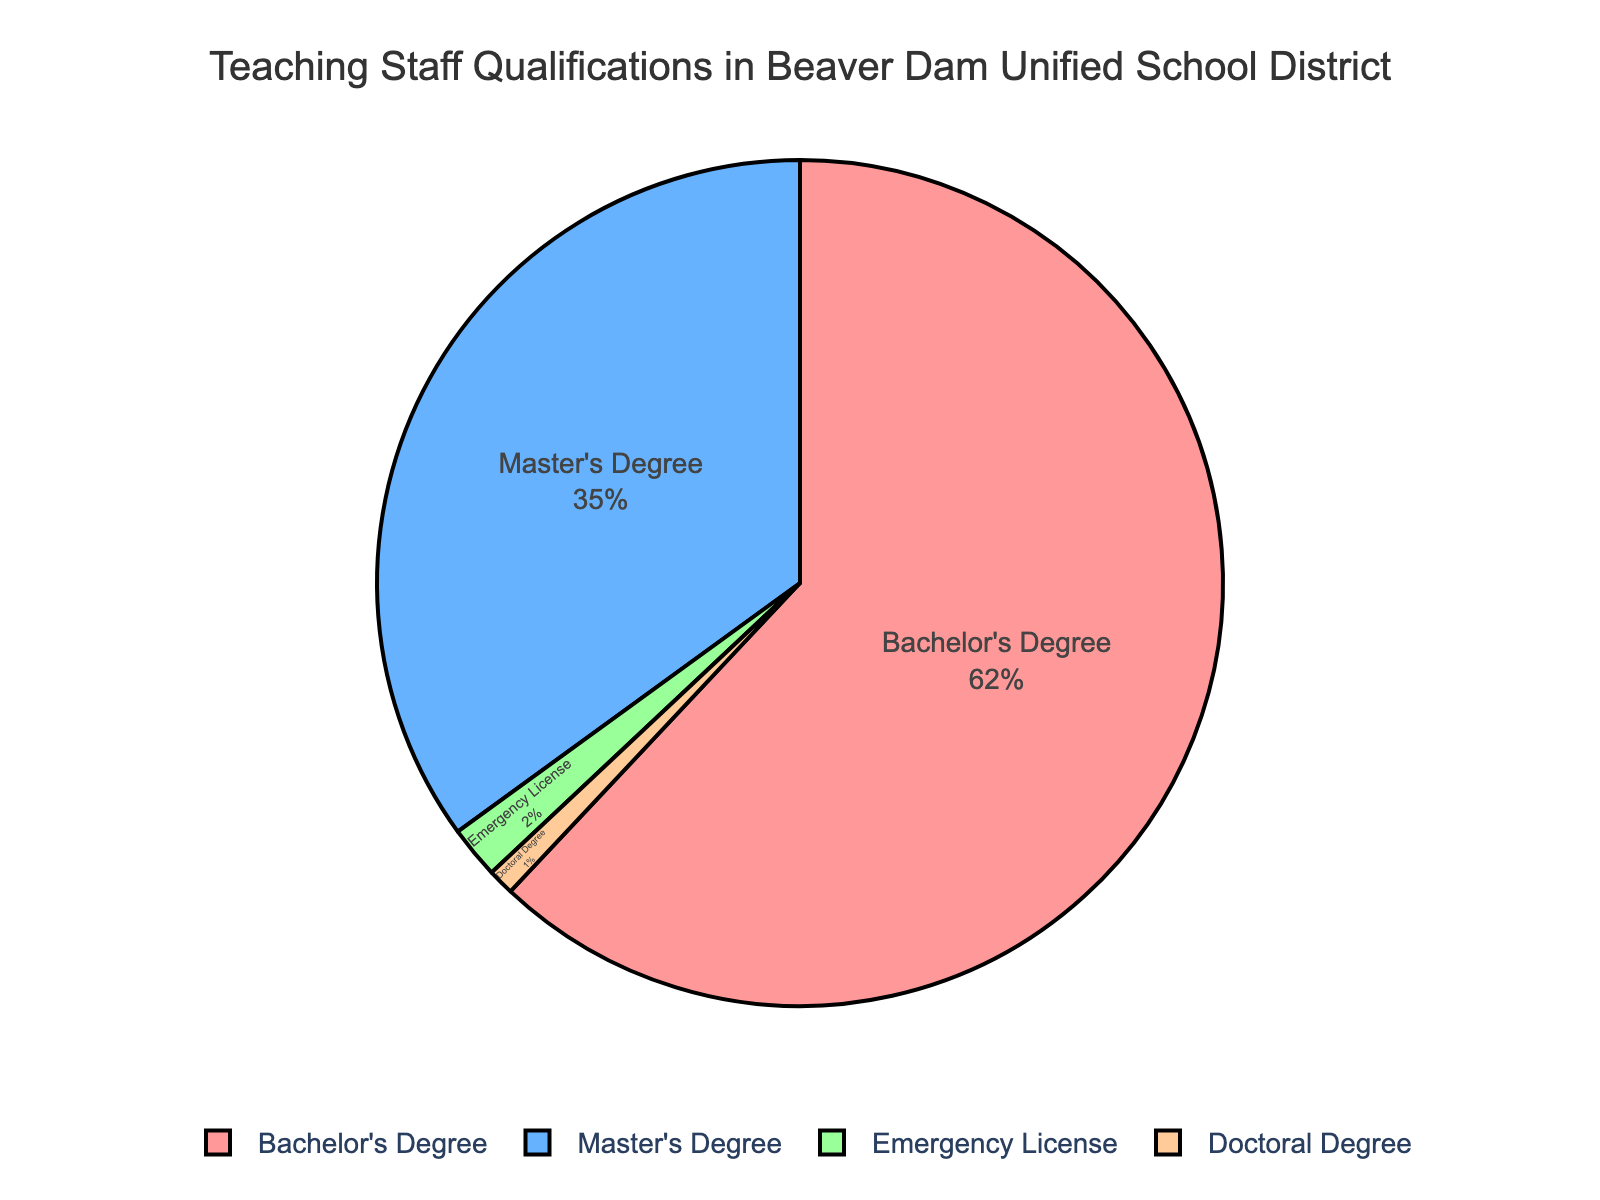What percentage of teachers in the Beaver Dam Unified School District have a Master's Degree? By examining the pie chart, we can see the segment labeled "Master's Degree" and its corresponding percentage.
Answer: 35% What is the difference in percentage between teachers with a Bachelor's Degree and those with an Emergency License? Subtract the percentage of teachers with an Emergency License from those with a Bachelor's Degree (62% - 2%).
Answer: 60% What percentage of teachers in the Beaver Dam Unified School District have advanced degrees (Master's or Doctoral)? Sum the percentages of teachers with Master's Degrees and Doctoral Degrees (35% + 1%).
Answer: 36% Which category has the smallest representation among the teaching staff in Beaver Dam Unified School District? Identify the smallest segment on the pie chart, labeled "Doctoral Degree."
Answer: Doctoral Degree How much larger is the percentage of teachers with a Master's Degree compared to those with a Doctoral Degree? Subtract the percentage of teachers with a Doctoral Degree from those with a Master's Degree (35% - 1%).
Answer: 34% What is the total percentage of teachers who do not have a standard degree (i.e., those with an Emergency License)? Locate the segment labeled "Emergency License" and note its percentage.
Answer: 2% How do the percentages of teachers with Bachelor's Degrees and Master's Degrees compare visually in terms of size on the pie chart? Observe the relative size of the segments labeled "Bachelor's Degree" and "Master's Degree"; the Bachelor's Degree segment is noticeably larger.
Answer: Bachelor's Degree segment is larger If you combine teachers with Emergency Licenses and Doctoral Degrees, what percentage of the total teaching staff do they represent? Sum the percentages for Emergency Licenses and Doctoral Degrees (2% + 1%).
Answer: 3% Among the qualifications listed, which color represents the Master's Degree segment in the pie chart? Look for the segment with the percentage labeled "Master's Degree" and identify its color.
Answer: Blue 